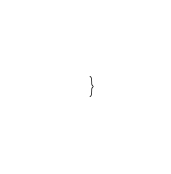Convert code to text. <code><loc_0><loc_0><loc_500><loc_500><_Kotlin_>}
</code> 